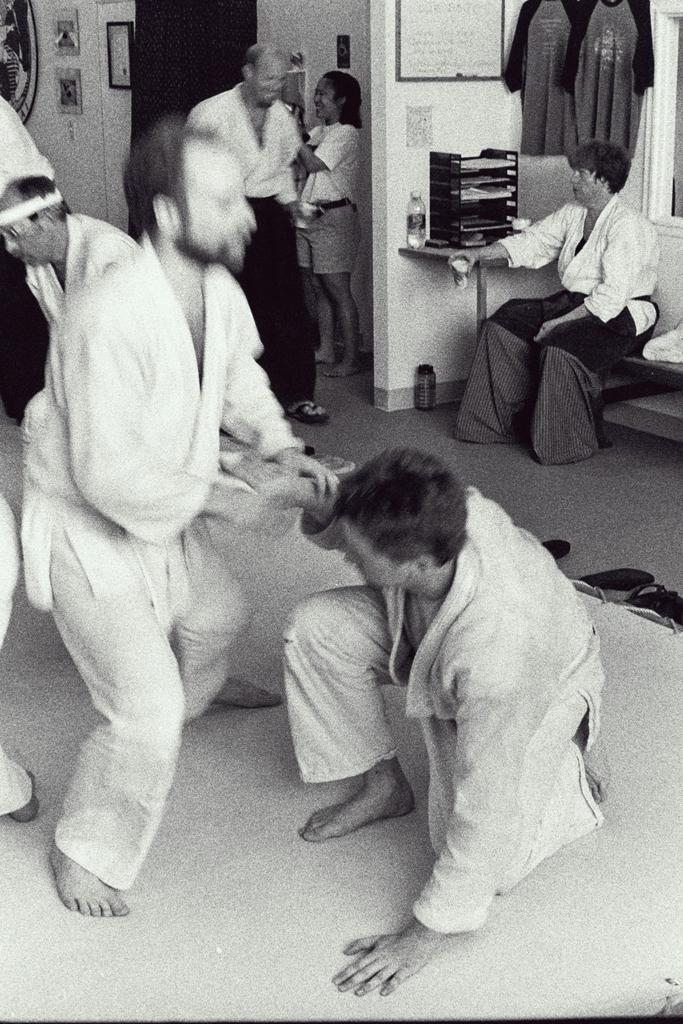How would you summarize this image in a sentence or two? In this picture there are two persons fighting. At the back there are two persons standing and there is a person sitting on the chair. There is a bottle and there are objects on the table. There are frames on the wall. At the top there are t-shirts hanging on the wall. At the bottom there is a bottle and there are footwear's. 